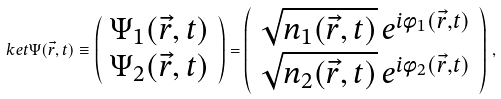<formula> <loc_0><loc_0><loc_500><loc_500>\ k e t { \Psi ( \vec { r } , t ) } \equiv \left ( \begin{array} { c } \Psi _ { 1 } ( \vec { r } , t ) \\ \Psi _ { 2 } ( \vec { r } , t ) \end{array} \right ) = \left ( \begin{array} { c } \sqrt { n _ { 1 } ( \vec { r } , t ) } \, e ^ { i \phi _ { 1 } ( \vec { r } , t ) } \\ \sqrt { n _ { 2 } ( \vec { r } , t ) } \, e ^ { i \phi _ { 2 } ( \vec { r } , t ) } \end{array} \right ) \, ,</formula> 